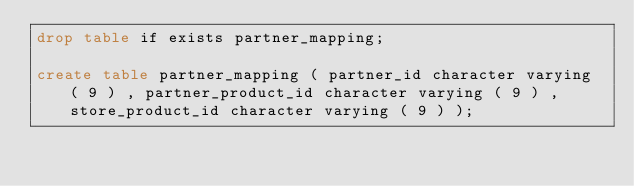<code> <loc_0><loc_0><loc_500><loc_500><_SQL_>drop table if exists partner_mapping;

create table partner_mapping ( partner_id character varying ( 9 ) , partner_product_id character varying ( 9 ) , store_product_id character varying ( 9 ) );</code> 